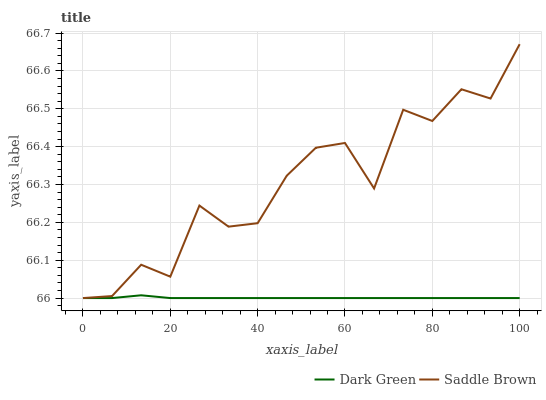Does Dark Green have the minimum area under the curve?
Answer yes or no. Yes. Does Saddle Brown have the maximum area under the curve?
Answer yes or no. Yes. Does Dark Green have the maximum area under the curve?
Answer yes or no. No. Is Dark Green the smoothest?
Answer yes or no. Yes. Is Saddle Brown the roughest?
Answer yes or no. Yes. Is Dark Green the roughest?
Answer yes or no. No. Does Saddle Brown have the highest value?
Answer yes or no. Yes. Does Dark Green have the highest value?
Answer yes or no. No. Does Dark Green intersect Saddle Brown?
Answer yes or no. Yes. Is Dark Green less than Saddle Brown?
Answer yes or no. No. Is Dark Green greater than Saddle Brown?
Answer yes or no. No. 